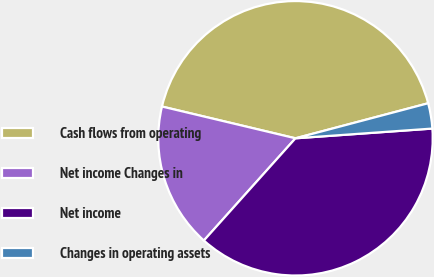Convert chart to OTSL. <chart><loc_0><loc_0><loc_500><loc_500><pie_chart><fcel>Cash flows from operating<fcel>Net income Changes in<fcel>Net income<fcel>Changes in operating assets<nl><fcel>42.17%<fcel>17.09%<fcel>37.76%<fcel>2.98%<nl></chart> 